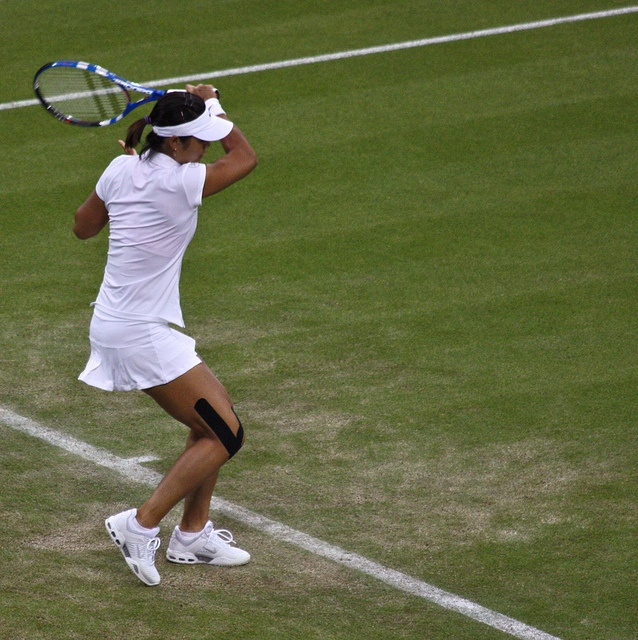Describe the objects in this image and their specific colors. I can see people in gray, lavender, darkgray, olive, and black tones and tennis racket in gray, darkgreen, black, and darkgray tones in this image. 